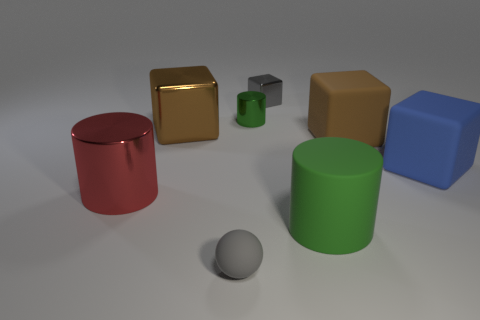Subtract all large cylinders. How many cylinders are left? 1 Subtract 2 cubes. How many cubes are left? 2 Subtract all gray cubes. How many cubes are left? 3 Subtract all green cubes. Subtract all brown balls. How many cubes are left? 4 Add 2 small cylinders. How many objects exist? 10 Subtract all spheres. How many objects are left? 7 Add 4 tiny gray balls. How many tiny gray balls are left? 5 Add 5 large brown matte spheres. How many large brown matte spheres exist? 5 Subtract 0 red balls. How many objects are left? 8 Subtract all cyan rubber cubes. Subtract all tiny green cylinders. How many objects are left? 7 